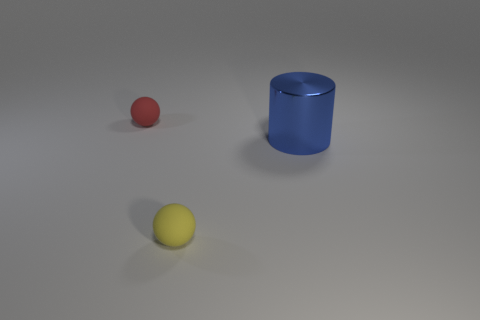What material is the yellow thing that is the same size as the red object?
Give a very brief answer. Rubber. What number of things are either tiny red matte spheres that are to the left of the blue cylinder or tiny balls in front of the shiny cylinder?
Provide a short and direct response. 2. What size is the other object that is made of the same material as the yellow object?
Provide a short and direct response. Small. How many metal things are either small objects or large blue things?
Your answer should be compact. 1. The red thing has what size?
Make the answer very short. Small. Do the red object and the yellow rubber ball have the same size?
Make the answer very short. Yes. There is a sphere that is in front of the large shiny thing; what is it made of?
Your answer should be compact. Rubber. What is the material of the other small thing that is the same shape as the yellow matte object?
Provide a short and direct response. Rubber. Is there a red sphere left of the object that is on the left side of the tiny yellow sphere?
Make the answer very short. No. Do the big blue thing and the small yellow object have the same shape?
Keep it short and to the point. No. 